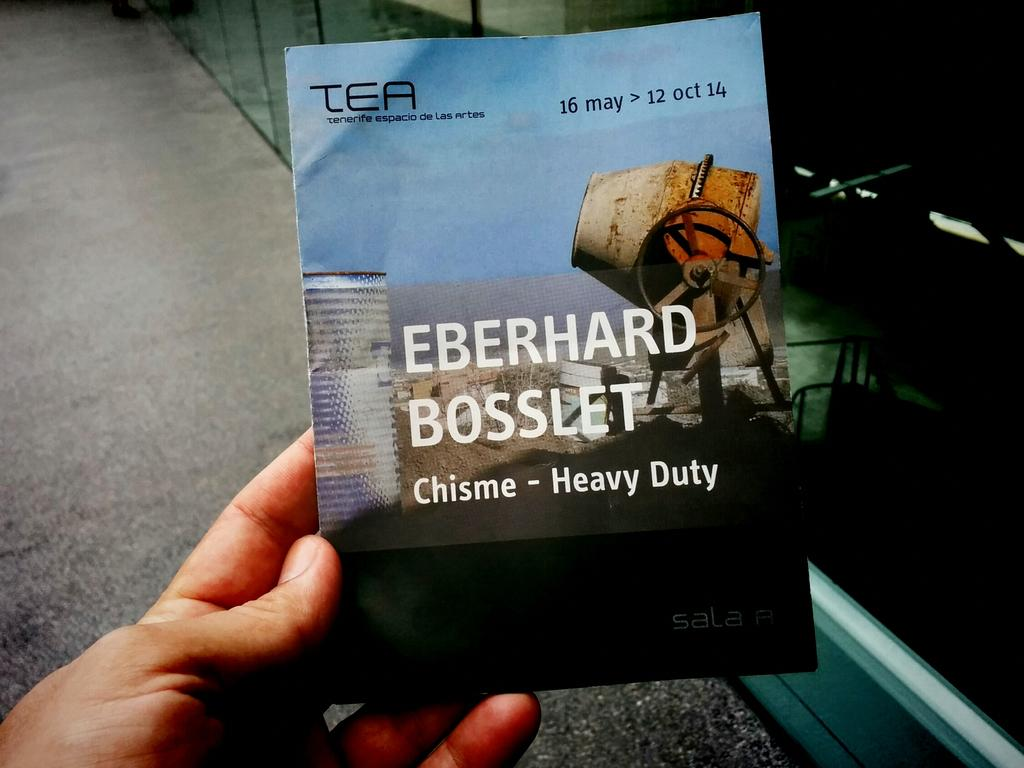What is being held by the human in the image? There is a paper in the hand of a human in the image. What colors are present on the paper? The paper has blue and black colors. What type of text can be seen on the paper? There are white and black words on the paper. What can be seen in the background of the image? There is a road visible in the background of the image. How does the human pull the paper in the image? There is no indication in the image that the human is pulling the paper. The paper is simply being held in the hand. 